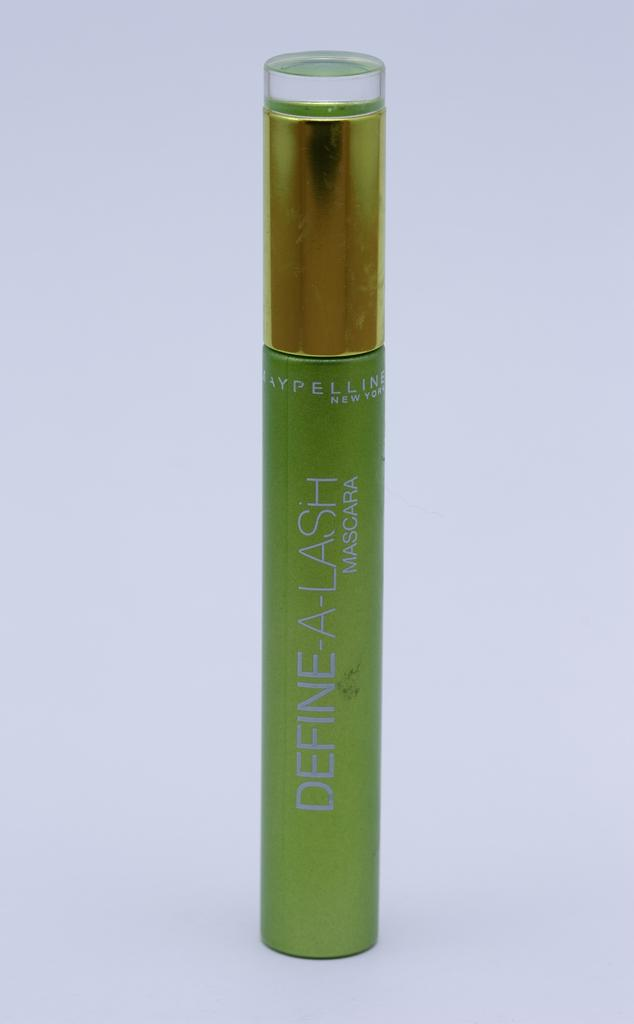<image>
Provide a brief description of the given image. green tube of define-a-lash mascara by maybelline new york 